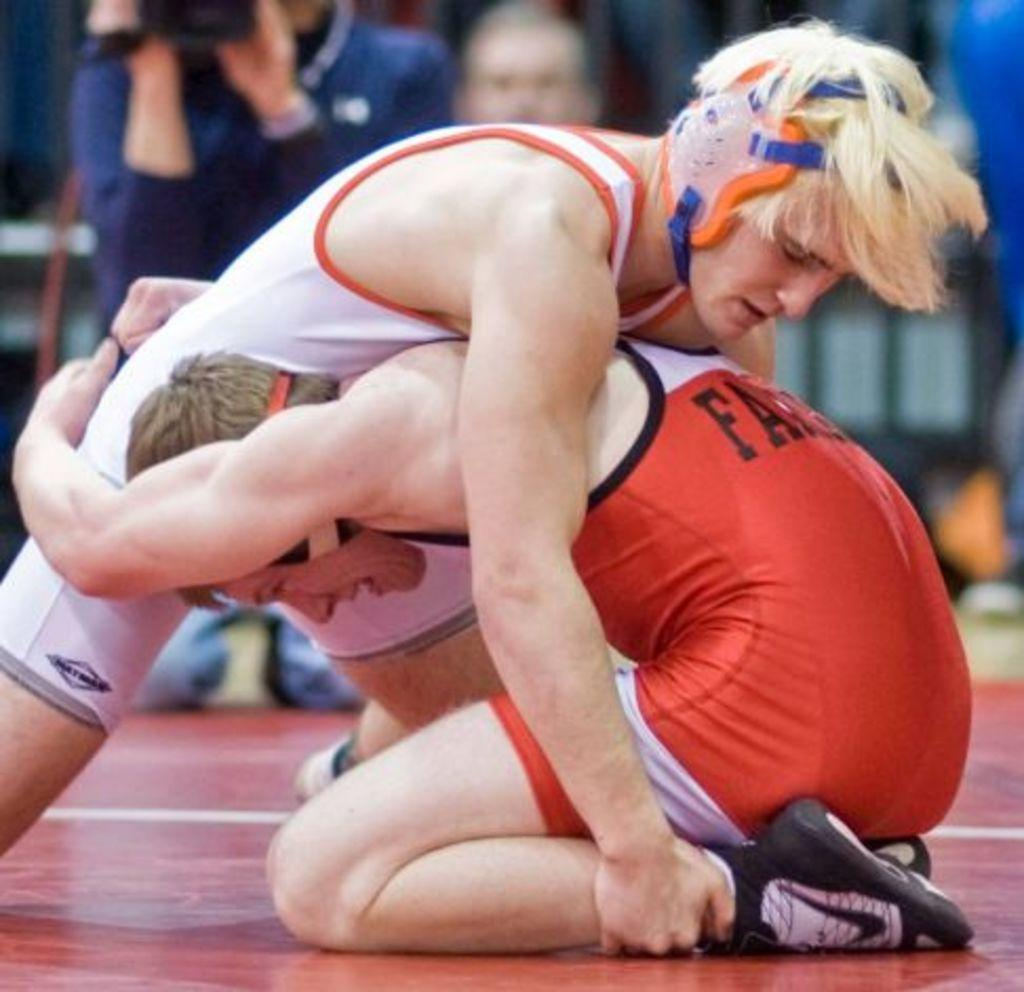<image>
Provide a brief description of the given image. Two boys wrestle on a gym floor. One's orange jersey has the letters FA on it but I can't make out the rest of the word. 